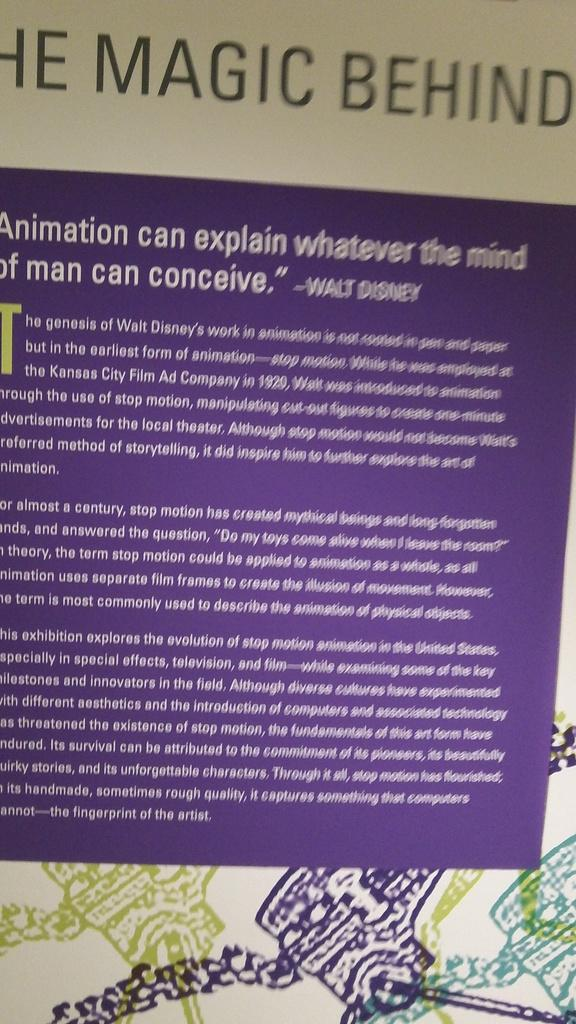Provide a one-sentence caption for the provided image. A purple sheet with the magic behind on it. 